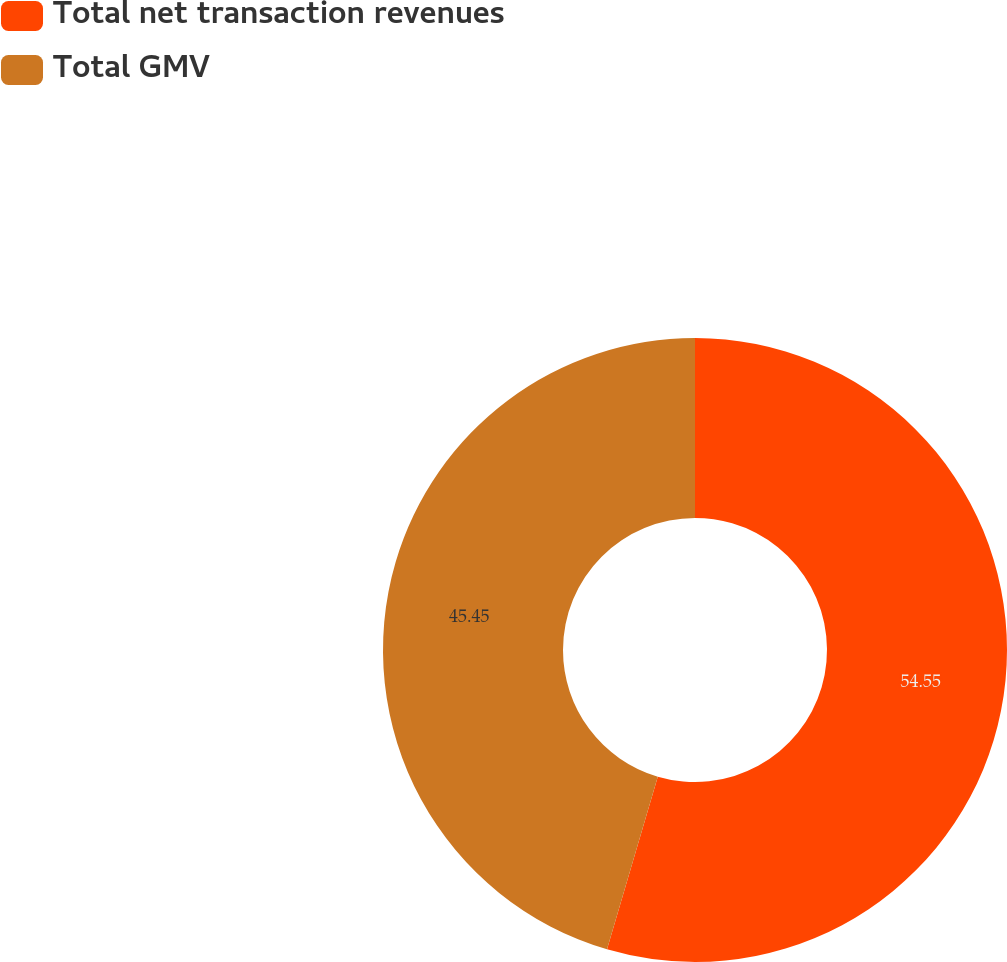Convert chart. <chart><loc_0><loc_0><loc_500><loc_500><pie_chart><fcel>Total net transaction revenues<fcel>Total GMV<nl><fcel>54.55%<fcel>45.45%<nl></chart> 